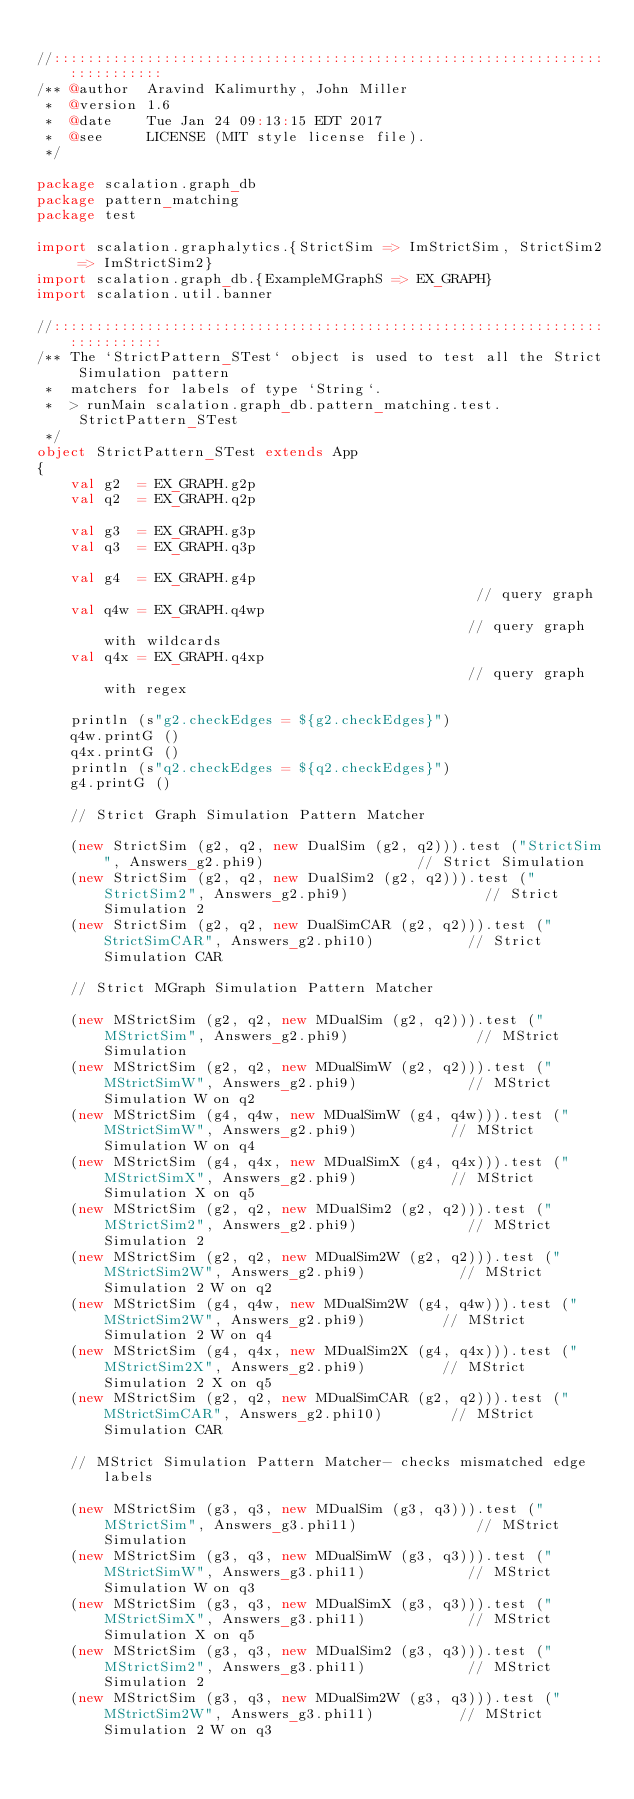Convert code to text. <code><loc_0><loc_0><loc_500><loc_500><_Scala_>
//::::::::::::::::::::::::::::::::::::::::::::::::::::::::::::::::::::::::::::
/** @author  Aravind Kalimurthy, John Miller
 *  @version 1.6
 *  @date    Tue Jan 24 09:13:15 EDT 2017
 *  @see     LICENSE (MIT style license file).
 */

package scalation.graph_db
package pattern_matching
package test

import scalation.graphalytics.{StrictSim => ImStrictSim, StrictSim2 => ImStrictSim2}
import scalation.graph_db.{ExampleMGraphS => EX_GRAPH}
import scalation.util.banner

//::::::::::::::::::::::::::::::::::::::::::::::::::::::::::::::::::::::::::::
/** The `StrictPattern_STest` object is used to test all the Strict Simulation pattern
 *  matchers for labels of type `String`.
 *  > runMain scalation.graph_db.pattern_matching.test.StrictPattern_STest
 */
object StrictPattern_STest extends App
{
    val g2  = EX_GRAPH.g2p
    val q2  = EX_GRAPH.q2p

    val g3  = EX_GRAPH.g3p
    val q3  = EX_GRAPH.q3p

    val g4  = EX_GRAPH.g4p                                             // query graph
    val q4w = EX_GRAPH.q4wp                                            // query graph with wildcards
    val q4x = EX_GRAPH.q4xp                                            // query graph with regex

    println (s"g2.checkEdges = ${g2.checkEdges}")
    q4w.printG ()
    q4x.printG ()
    println (s"q2.checkEdges = ${q2.checkEdges}")
    g4.printG ()

    // Strict Graph Simulation Pattern Matcher

    (new StrictSim (g2, q2, new DualSim (g2, q2))).test ("StrictSim", Answers_g2.phi9)                  // Strict Simulation
    (new StrictSim (g2, q2, new DualSim2 (g2, q2))).test ("StrictSim2", Answers_g2.phi9)                // Strict Simulation 2
    (new StrictSim (g2, q2, new DualSimCAR (g2, q2))).test ("StrictSimCAR", Answers_g2.phi10)           // Strict Simulation CAR

    // Strict MGraph Simulation Pattern Matcher

    (new MStrictSim (g2, q2, new MDualSim (g2, q2))).test ("MStrictSim", Answers_g2.phi9)               // MStrict Simulation
    (new MStrictSim (g2, q2, new MDualSimW (g2, q2))).test ("MStrictSimW", Answers_g2.phi9)             // MStrict Simulation W on q2
    (new MStrictSim (g4, q4w, new MDualSimW (g4, q4w))).test ("MStrictSimW", Answers_g2.phi9)           // MStrict Simulation W on q4
    (new MStrictSim (g4, q4x, new MDualSimX (g4, q4x))).test ("MStrictSimX", Answers_g2.phi9)           // MStrict Simulation X on q5
    (new MStrictSim (g2, q2, new MDualSim2 (g2, q2))).test ("MStrictSim2", Answers_g2.phi9)             // MStrict Simulation 2
    (new MStrictSim (g2, q2, new MDualSim2W (g2, q2))).test ("MStrictSim2W", Answers_g2.phi9)           // MStrict Simulation 2 W on q2
    (new MStrictSim (g4, q4w, new MDualSim2W (g4, q4w))).test ("MStrictSim2W", Answers_g2.phi9)         // MStrict Simulation 2 W on q4
    (new MStrictSim (g4, q4x, new MDualSim2X (g4, q4x))).test ("MStrictSim2X", Answers_g2.phi9)         // MStrict Simulation 2 X on q5
    (new MStrictSim (g2, q2, new MDualSimCAR (g2, q2))).test ("MStrictSimCAR", Answers_g2.phi10)        // MStrict Simulation CAR

    // MStrict Simulation Pattern Matcher- checks mismatched edge labels

    (new MStrictSim (g3, q3, new MDualSim (g3, q3))).test ("MStrictSim", Answers_g3.phi11)              // MStrict Simulation
    (new MStrictSim (g3, q3, new MDualSimW (g3, q3))).test ("MStrictSimW", Answers_g3.phi11)            // MStrict Simulation W on q3
    (new MStrictSim (g3, q3, new MDualSimX (g3, q3))).test ("MStrictSimX", Answers_g3.phi11)            // MStrict Simulation X on q5
    (new MStrictSim (g3, q3, new MDualSim2 (g3, q3))).test ("MStrictSim2", Answers_g3.phi11)            // MStrict Simulation 2
    (new MStrictSim (g3, q3, new MDualSim2W (g3, q3))).test ("MStrictSim2W", Answers_g3.phi11)          // MStrict Simulation 2 W on q3</code> 